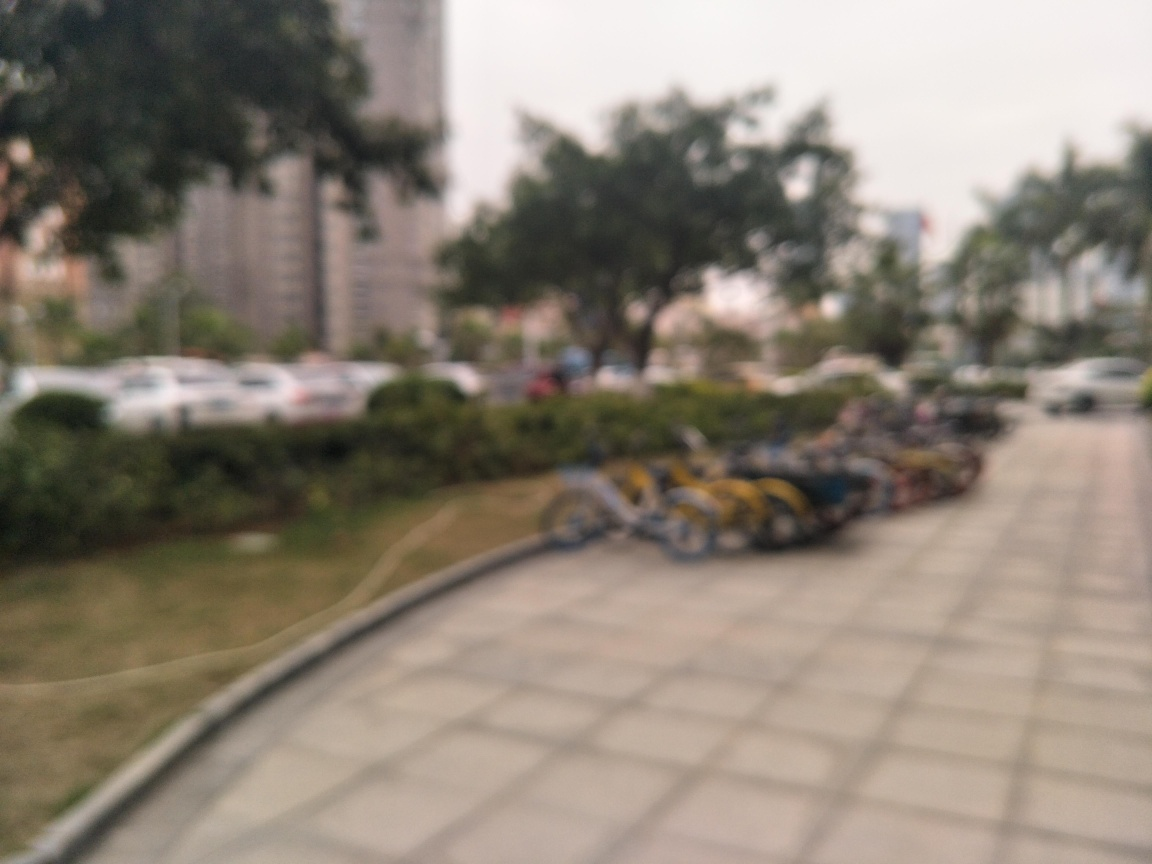Could this image be improved in post-processing to make it clearer? If the blur is due to focus issues, clarity can only be improved to a limited extent through sharpening tools in post-processing software. However, this wouldn't fully correct the focus, just make the existing details slightly more defined. 